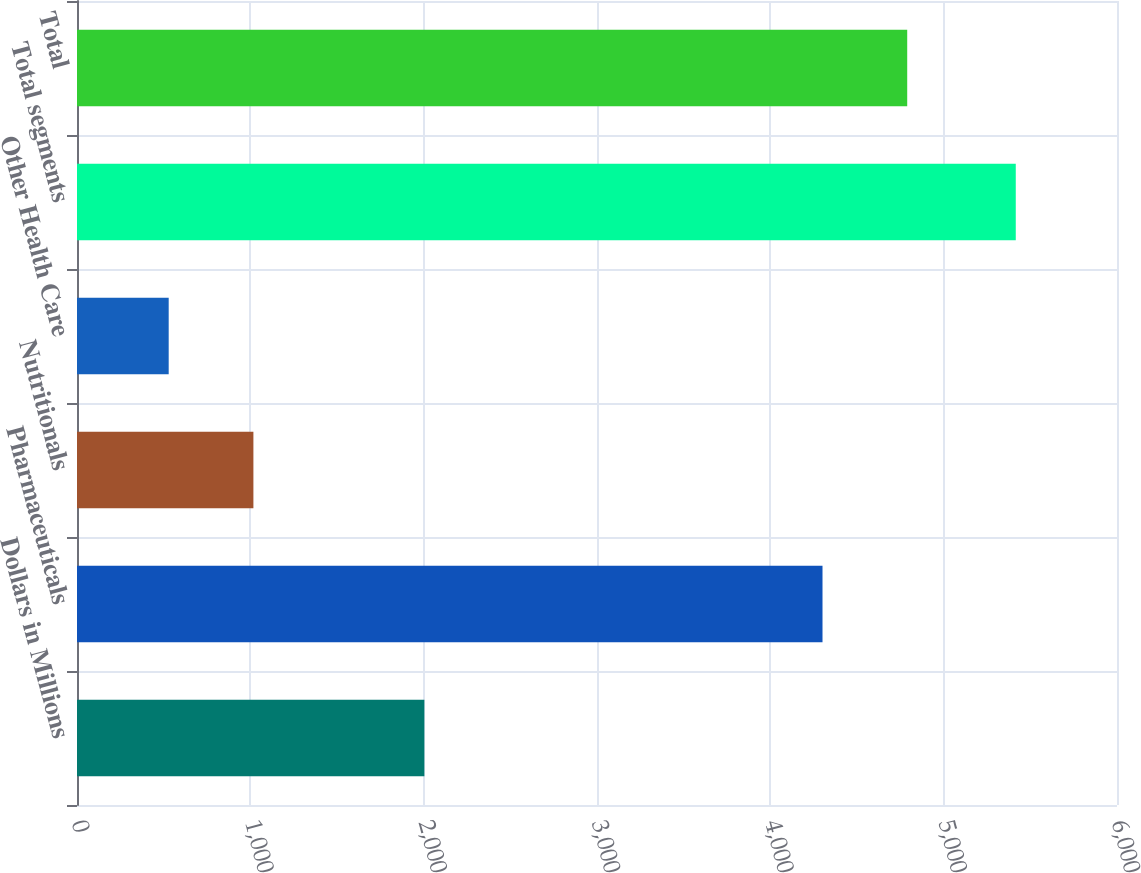<chart> <loc_0><loc_0><loc_500><loc_500><bar_chart><fcel>Dollars in Millions<fcel>Pharmaceuticals<fcel>Nutritionals<fcel>Other Health Care<fcel>Total segments<fcel>Total<nl><fcel>2004<fcel>4301<fcel>1017.7<fcel>529<fcel>5416<fcel>4789.7<nl></chart> 